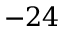<formula> <loc_0><loc_0><loc_500><loc_500>- 2 4</formula> 